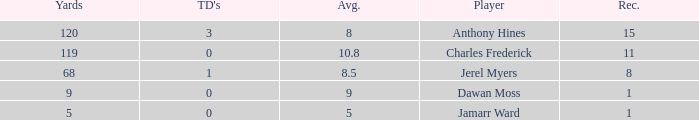What is the highest number of TDs when the Avg is larger than 8.5 and the Rec is less than 1? None. 